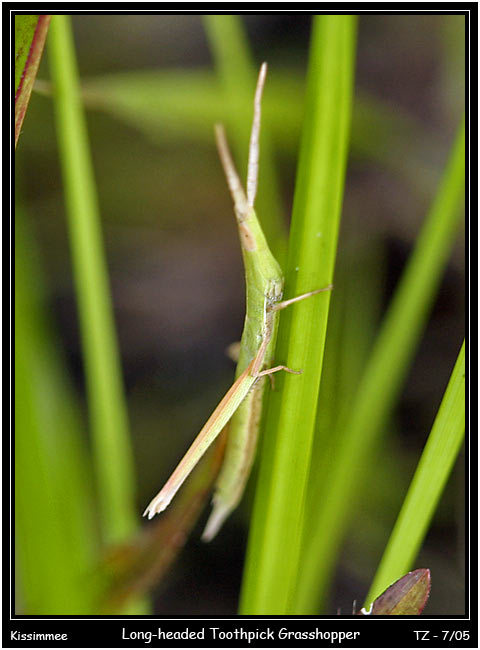Your task is to identify the object category of a real-world image. The image can contain different objects like an American flag, bear, cake, and more. Analyze the shape, color, and texture of the object to determine its category. Consider the specific details of the label. Provide the name of the object based on your classification. The object in the image is an insect from the orthopteran family, specifically a grasshopper. The label "Long-headed Toothpick Grasshopper" provides the common name of the species. Based on its slender, elongated body and the matching coloration with the plant stems, it can be classified as a Toothpick Grasshopper, which is known for its stick-like appearance. This physical adaptation is a form of camouflage to evade predators by blending in with the vegetation it inhabits. The "Long-headed" descriptor indicates a particular morphological feature that differentiates it from other grasshoppers, which is the extended head that resembles the twigs among which it lives. The name given in the label is consistent with the observed characteristics and thus, the object can be accurately categorized as a Long-headed Toothpick Grasshopper. 